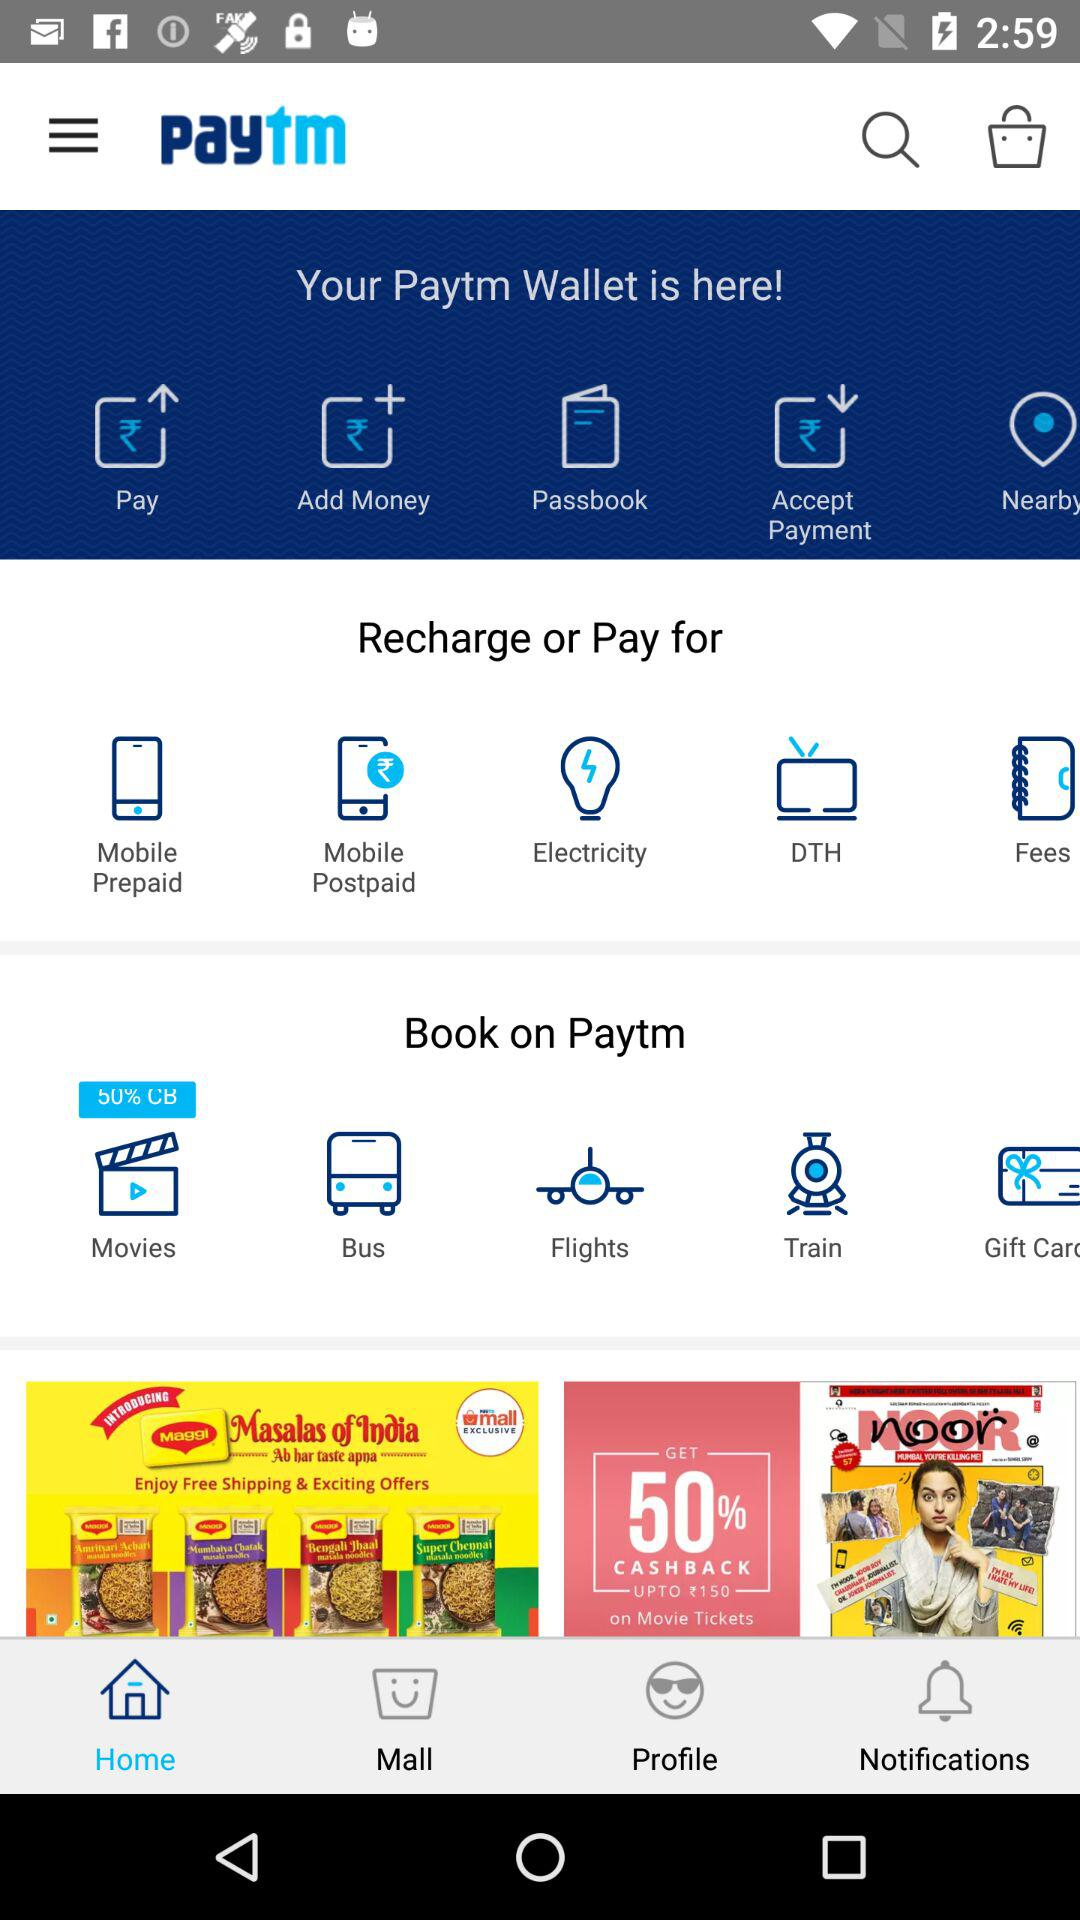Which tab is selected? The selected tab is "Home". 